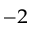Convert formula to latex. <formula><loc_0><loc_0><loc_500><loc_500>^ { - 2 }</formula> 